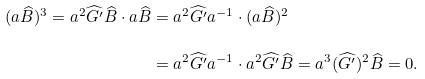<formula> <loc_0><loc_0><loc_500><loc_500>( a \widehat { B } ) ^ { 3 } = a ^ { 2 } \widehat { G ^ { \prime } } \widehat { B } \cdot a \widehat { B } & = a ^ { 2 } \widehat { G ^ { \prime } } a ^ { - 1 } \cdot ( a \widehat { B } ) ^ { 2 } \\ & = a ^ { 2 } \widehat { G ^ { \prime } } a ^ { - 1 } \cdot a ^ { 2 } \widehat { G ^ { \prime } } \widehat { B } = a ^ { 3 } ( \widehat { G ^ { \prime } } ) ^ { 2 } \widehat { B } = 0 .</formula> 